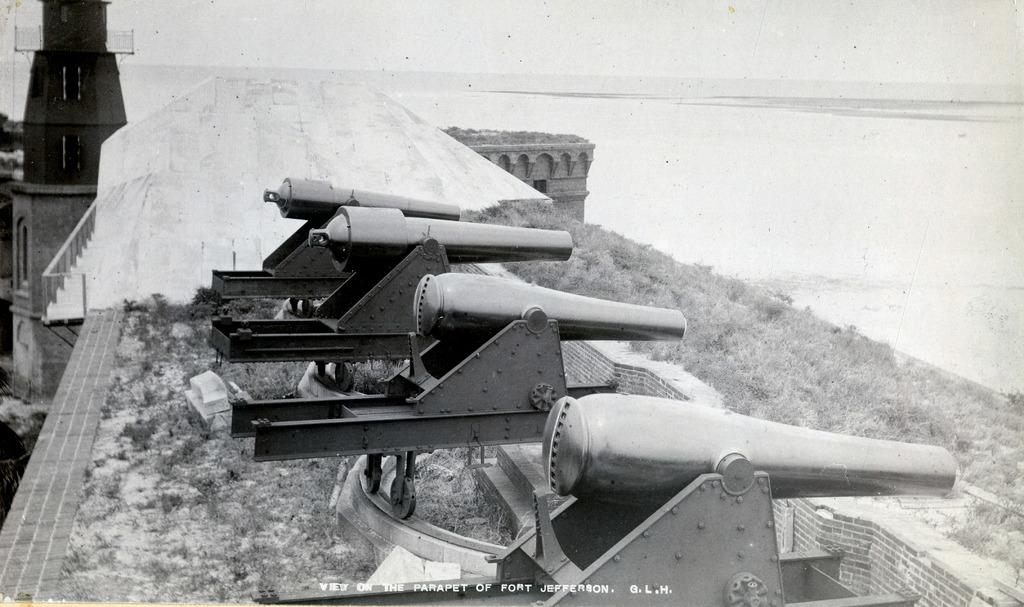What type of weapon is present in the image? There are cannon guns in the image. Where are the cannon guns located? The cannon guns are on top of a fort. What can be seen beside the cannon guns? The fort is visible beside the cannon guns. What type of vegetation is present in the image? There is grass in the image. What is written or depicted at the bottom of the image? There is some text at the bottom of the image. What type of dinner is being served in the image? There is no dinner present in the image; it features cannon guns on a fort with grass and text. 